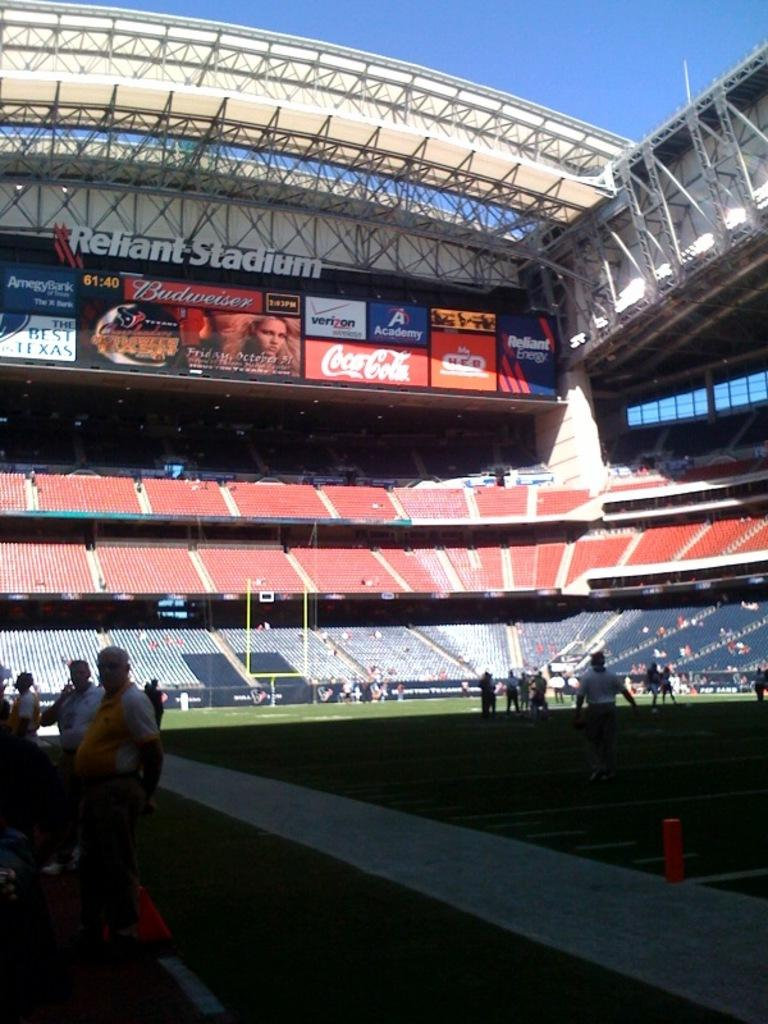<image>
Present a compact description of the photo's key features. A view from the inside of a stadium of various advertisements including Coca Cola and Reliant Energy. 